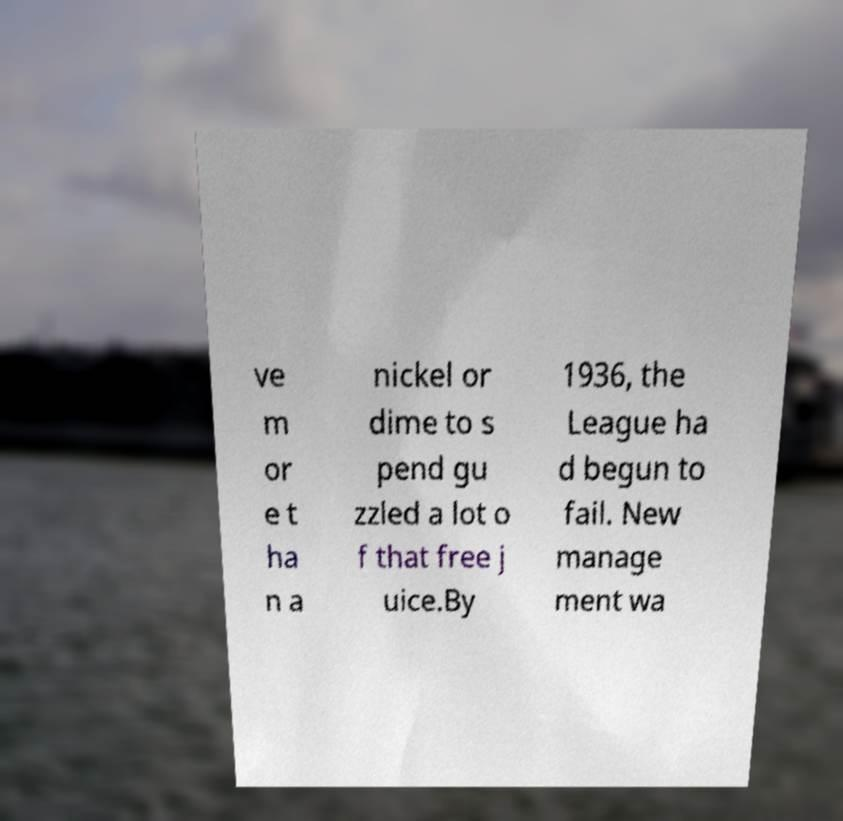There's text embedded in this image that I need extracted. Can you transcribe it verbatim? ve m or e t ha n a nickel or dime to s pend gu zzled a lot o f that free j uice.By 1936, the League ha d begun to fail. New manage ment wa 